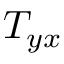<formula> <loc_0><loc_0><loc_500><loc_500>T _ { y x }</formula> 